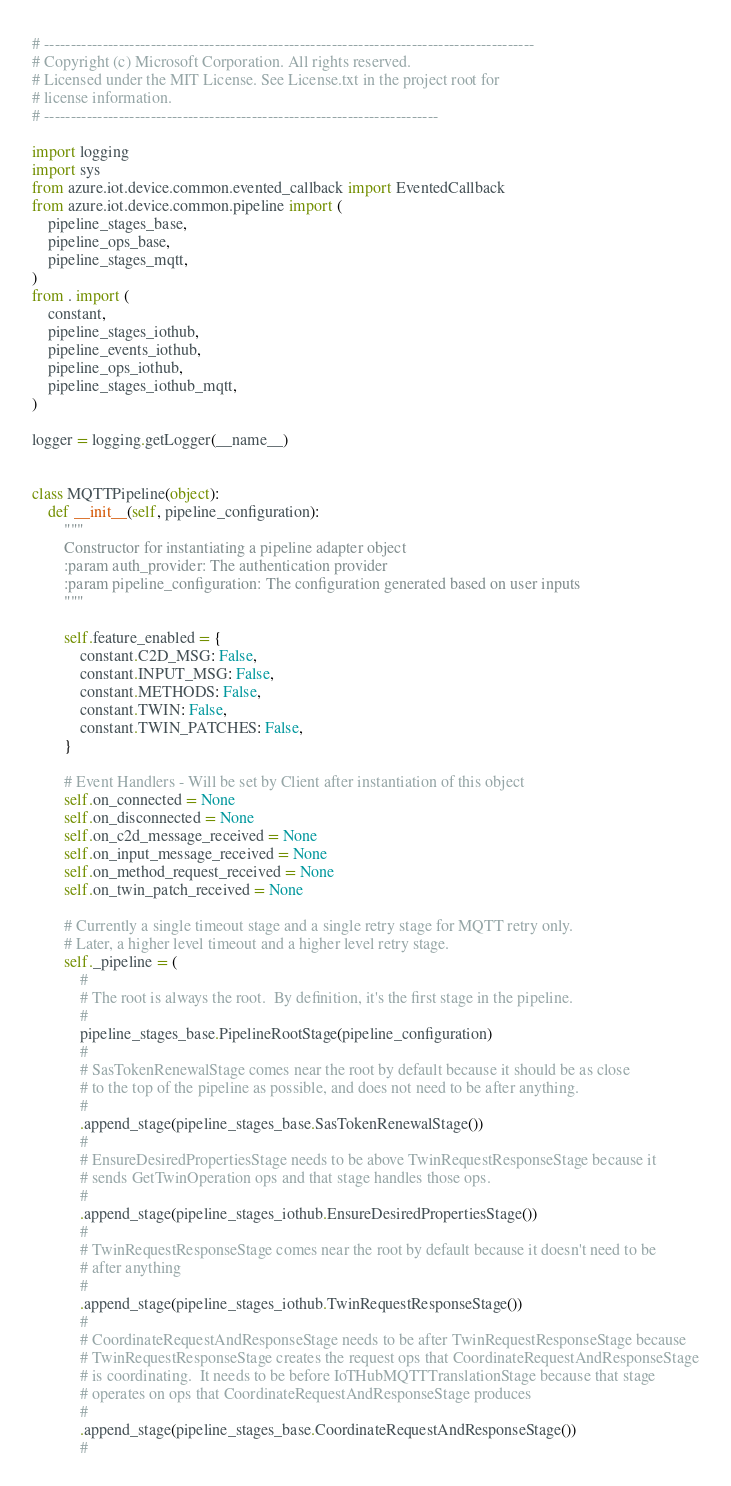<code> <loc_0><loc_0><loc_500><loc_500><_Python_># --------------------------------------------------------------------------------------------
# Copyright (c) Microsoft Corporation. All rights reserved.
# Licensed under the MIT License. See License.txt in the project root for
# license information.
# --------------------------------------------------------------------------

import logging
import sys
from azure.iot.device.common.evented_callback import EventedCallback
from azure.iot.device.common.pipeline import (
    pipeline_stages_base,
    pipeline_ops_base,
    pipeline_stages_mqtt,
)
from . import (
    constant,
    pipeline_stages_iothub,
    pipeline_events_iothub,
    pipeline_ops_iothub,
    pipeline_stages_iothub_mqtt,
)

logger = logging.getLogger(__name__)


class MQTTPipeline(object):
    def __init__(self, pipeline_configuration):
        """
        Constructor for instantiating a pipeline adapter object
        :param auth_provider: The authentication provider
        :param pipeline_configuration: The configuration generated based on user inputs
        """

        self.feature_enabled = {
            constant.C2D_MSG: False,
            constant.INPUT_MSG: False,
            constant.METHODS: False,
            constant.TWIN: False,
            constant.TWIN_PATCHES: False,
        }

        # Event Handlers - Will be set by Client after instantiation of this object
        self.on_connected = None
        self.on_disconnected = None
        self.on_c2d_message_received = None
        self.on_input_message_received = None
        self.on_method_request_received = None
        self.on_twin_patch_received = None

        # Currently a single timeout stage and a single retry stage for MQTT retry only.
        # Later, a higher level timeout and a higher level retry stage.
        self._pipeline = (
            #
            # The root is always the root.  By definition, it's the first stage in the pipeline.
            #
            pipeline_stages_base.PipelineRootStage(pipeline_configuration)
            #
            # SasTokenRenewalStage comes near the root by default because it should be as close
            # to the top of the pipeline as possible, and does not need to be after anything.
            #
            .append_stage(pipeline_stages_base.SasTokenRenewalStage())
            #
            # EnsureDesiredPropertiesStage needs to be above TwinRequestResponseStage because it
            # sends GetTwinOperation ops and that stage handles those ops.
            #
            .append_stage(pipeline_stages_iothub.EnsureDesiredPropertiesStage())
            #
            # TwinRequestResponseStage comes near the root by default because it doesn't need to be
            # after anything
            #
            .append_stage(pipeline_stages_iothub.TwinRequestResponseStage())
            #
            # CoordinateRequestAndResponseStage needs to be after TwinRequestResponseStage because
            # TwinRequestResponseStage creates the request ops that CoordinateRequestAndResponseStage
            # is coordinating.  It needs to be before IoTHubMQTTTranslationStage because that stage
            # operates on ops that CoordinateRequestAndResponseStage produces
            #
            .append_stage(pipeline_stages_base.CoordinateRequestAndResponseStage())
            #</code> 